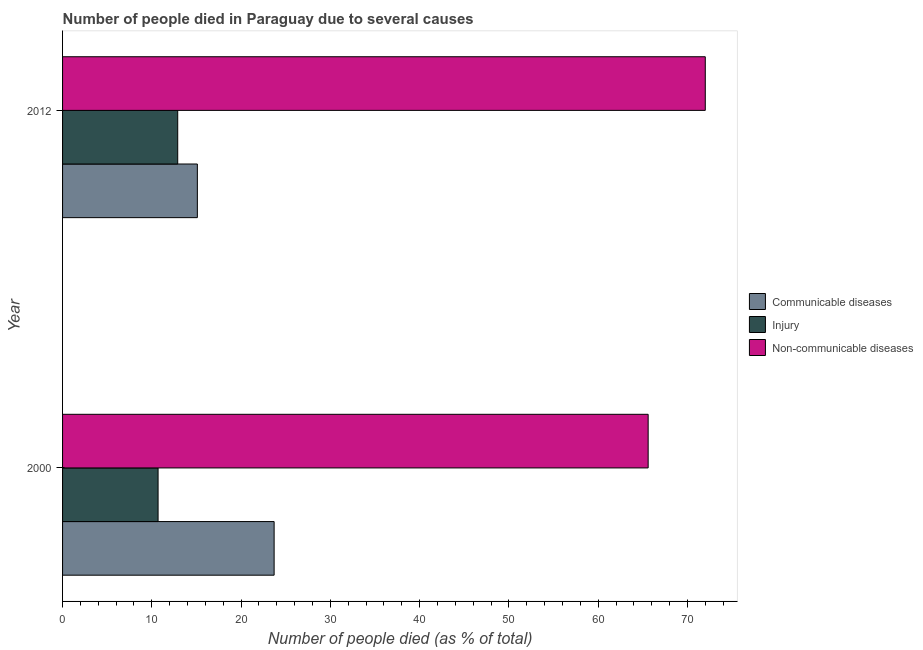How many groups of bars are there?
Your response must be concise. 2. Are the number of bars on each tick of the Y-axis equal?
Offer a very short reply. Yes. What is the label of the 1st group of bars from the top?
Your answer should be compact. 2012. In how many cases, is the number of bars for a given year not equal to the number of legend labels?
Provide a short and direct response. 0. What is the number of people who died of communicable diseases in 2012?
Ensure brevity in your answer.  15.1. Across all years, what is the maximum number of people who died of injury?
Give a very brief answer. 12.9. In which year was the number of people who died of injury minimum?
Provide a succinct answer. 2000. What is the total number of people who died of injury in the graph?
Your answer should be compact. 23.6. What is the difference between the number of people who dies of non-communicable diseases in 2000 and the number of people who died of communicable diseases in 2012?
Make the answer very short. 50.5. What is the average number of people who dies of non-communicable diseases per year?
Your answer should be compact. 68.8. In the year 2012, what is the difference between the number of people who dies of non-communicable diseases and number of people who died of communicable diseases?
Your response must be concise. 56.9. What is the ratio of the number of people who dies of non-communicable diseases in 2000 to that in 2012?
Give a very brief answer. 0.91. Is the difference between the number of people who died of communicable diseases in 2000 and 2012 greater than the difference between the number of people who died of injury in 2000 and 2012?
Keep it short and to the point. Yes. What does the 2nd bar from the top in 2012 represents?
Give a very brief answer. Injury. What does the 2nd bar from the bottom in 2000 represents?
Your answer should be very brief. Injury. Is it the case that in every year, the sum of the number of people who died of communicable diseases and number of people who died of injury is greater than the number of people who dies of non-communicable diseases?
Provide a short and direct response. No. How many years are there in the graph?
Offer a very short reply. 2. What is the difference between two consecutive major ticks on the X-axis?
Offer a terse response. 10. Does the graph contain any zero values?
Your answer should be very brief. No. Does the graph contain grids?
Your answer should be compact. No. Where does the legend appear in the graph?
Ensure brevity in your answer.  Center right. How are the legend labels stacked?
Your answer should be very brief. Vertical. What is the title of the graph?
Make the answer very short. Number of people died in Paraguay due to several causes. Does "Profit Tax" appear as one of the legend labels in the graph?
Offer a very short reply. No. What is the label or title of the X-axis?
Your response must be concise. Number of people died (as % of total). What is the Number of people died (as % of total) of Communicable diseases in 2000?
Keep it short and to the point. 23.7. What is the Number of people died (as % of total) in Non-communicable diseases in 2000?
Your answer should be very brief. 65.6. What is the Number of people died (as % of total) in Communicable diseases in 2012?
Ensure brevity in your answer.  15.1. What is the Number of people died (as % of total) of Non-communicable diseases in 2012?
Offer a terse response. 72. Across all years, what is the maximum Number of people died (as % of total) in Communicable diseases?
Your answer should be compact. 23.7. Across all years, what is the maximum Number of people died (as % of total) of Injury?
Your answer should be compact. 12.9. Across all years, what is the maximum Number of people died (as % of total) in Non-communicable diseases?
Your answer should be very brief. 72. Across all years, what is the minimum Number of people died (as % of total) of Communicable diseases?
Your answer should be compact. 15.1. Across all years, what is the minimum Number of people died (as % of total) in Injury?
Offer a terse response. 10.7. Across all years, what is the minimum Number of people died (as % of total) in Non-communicable diseases?
Ensure brevity in your answer.  65.6. What is the total Number of people died (as % of total) of Communicable diseases in the graph?
Your answer should be compact. 38.8. What is the total Number of people died (as % of total) of Injury in the graph?
Your response must be concise. 23.6. What is the total Number of people died (as % of total) in Non-communicable diseases in the graph?
Offer a terse response. 137.6. What is the difference between the Number of people died (as % of total) in Communicable diseases in 2000 and the Number of people died (as % of total) in Non-communicable diseases in 2012?
Provide a succinct answer. -48.3. What is the difference between the Number of people died (as % of total) in Injury in 2000 and the Number of people died (as % of total) in Non-communicable diseases in 2012?
Provide a succinct answer. -61.3. What is the average Number of people died (as % of total) of Injury per year?
Your response must be concise. 11.8. What is the average Number of people died (as % of total) of Non-communicable diseases per year?
Give a very brief answer. 68.8. In the year 2000, what is the difference between the Number of people died (as % of total) in Communicable diseases and Number of people died (as % of total) in Non-communicable diseases?
Offer a very short reply. -41.9. In the year 2000, what is the difference between the Number of people died (as % of total) in Injury and Number of people died (as % of total) in Non-communicable diseases?
Provide a succinct answer. -54.9. In the year 2012, what is the difference between the Number of people died (as % of total) in Communicable diseases and Number of people died (as % of total) in Non-communicable diseases?
Make the answer very short. -56.9. In the year 2012, what is the difference between the Number of people died (as % of total) in Injury and Number of people died (as % of total) in Non-communicable diseases?
Keep it short and to the point. -59.1. What is the ratio of the Number of people died (as % of total) of Communicable diseases in 2000 to that in 2012?
Your answer should be compact. 1.57. What is the ratio of the Number of people died (as % of total) in Injury in 2000 to that in 2012?
Keep it short and to the point. 0.83. What is the ratio of the Number of people died (as % of total) of Non-communicable diseases in 2000 to that in 2012?
Offer a very short reply. 0.91. What is the difference between the highest and the second highest Number of people died (as % of total) of Injury?
Your answer should be compact. 2.2. 